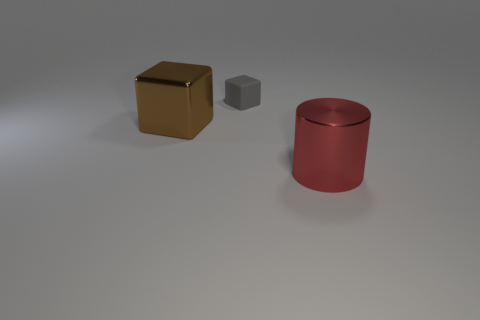How many things are either small gray objects or small red things?
Make the answer very short. 1. There is a big thing left of the matte block; what is its color?
Offer a very short reply. Brown. Are there fewer brown cubes that are on the right side of the metal cube than small cubes?
Offer a very short reply. Yes. Is there anything else that is the same size as the matte object?
Give a very brief answer. No. Are the red object and the big cube made of the same material?
Your answer should be compact. Yes. What number of objects are either big red shiny things on the right side of the matte cube or large shiny objects that are in front of the brown object?
Your answer should be compact. 1. Are there any cubes of the same size as the cylinder?
Your response must be concise. Yes. The other object that is the same shape as the tiny rubber object is what color?
Give a very brief answer. Brown. There is a big metal thing that is in front of the shiny block; are there any tiny gray objects that are right of it?
Offer a very short reply. No. There is a thing that is behind the brown shiny cube; is it the same shape as the brown shiny object?
Keep it short and to the point. Yes. 